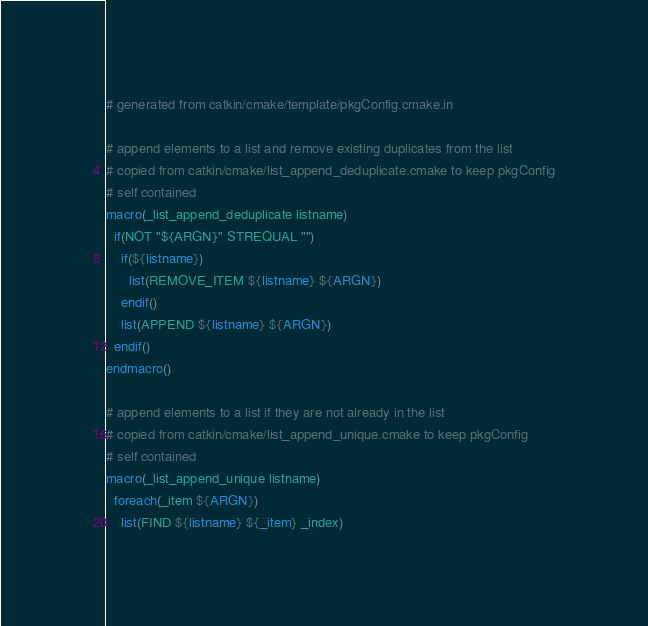<code> <loc_0><loc_0><loc_500><loc_500><_CMake_># generated from catkin/cmake/template/pkgConfig.cmake.in

# append elements to a list and remove existing duplicates from the list
# copied from catkin/cmake/list_append_deduplicate.cmake to keep pkgConfig
# self contained
macro(_list_append_deduplicate listname)
  if(NOT "${ARGN}" STREQUAL "")
    if(${listname})
      list(REMOVE_ITEM ${listname} ${ARGN})
    endif()
    list(APPEND ${listname} ${ARGN})
  endif()
endmacro()

# append elements to a list if they are not already in the list
# copied from catkin/cmake/list_append_unique.cmake to keep pkgConfig
# self contained
macro(_list_append_unique listname)
  foreach(_item ${ARGN})
    list(FIND ${listname} ${_item} _index)</code> 